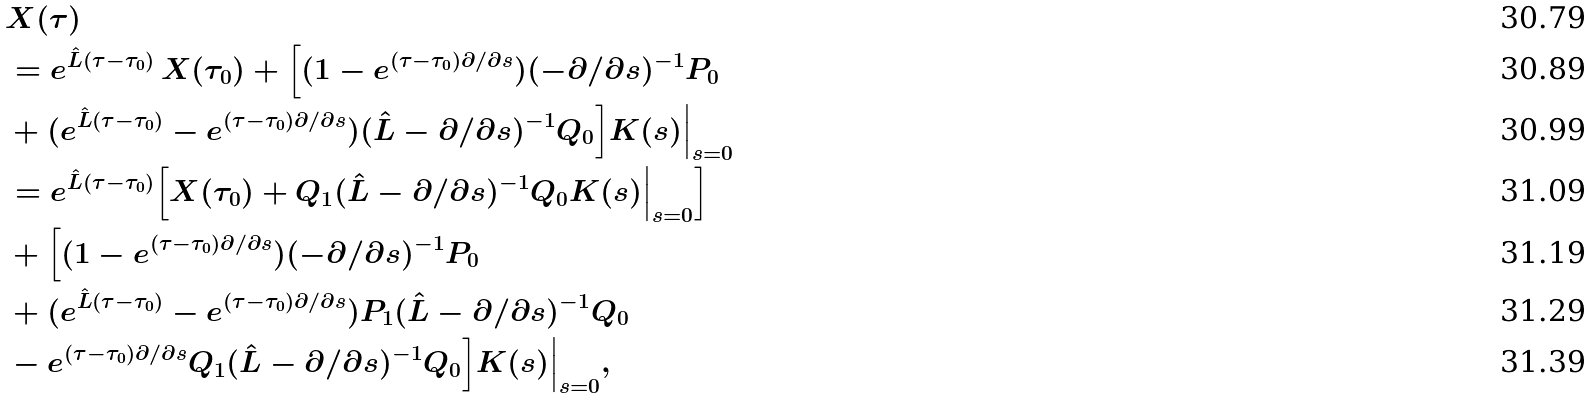<formula> <loc_0><loc_0><loc_500><loc_500>& X ( \tau ) \\ & = e ^ { \hat { L } ( \tau - \tau _ { 0 } ) } \, X ( \tau _ { 0 } ) + \Big [ ( 1 - e ^ { ( \tau - \tau _ { 0 } ) \partial / \partial s } ) ( - \partial / \partial s ) ^ { - 1 } P _ { 0 } \\ & + ( e ^ { \hat { L } ( \tau - \tau _ { 0 } ) } - e ^ { ( \tau - \tau _ { 0 } ) \partial / \partial s } ) ( \hat { L } - \partial / \partial s ) ^ { - 1 } Q _ { 0 } \Big ] K ( s ) \Big | _ { s = 0 } \\ & = e ^ { \hat { L } ( \tau - \tau _ { 0 } ) } \Big [ X ( \tau _ { 0 } ) + Q _ { 1 } ( \hat { L } - \partial / \partial s ) ^ { - 1 } Q _ { 0 } K ( s ) \Big | _ { s = 0 } \Big ] \\ & + \Big [ ( 1 - e ^ { ( \tau - \tau _ { 0 } ) \partial / \partial s } ) ( - \partial / \partial s ) ^ { - 1 } P _ { 0 } \\ & + ( e ^ { \hat { L } ( \tau - \tau _ { 0 } ) } - e ^ { ( \tau - \tau _ { 0 } ) \partial / \partial s } ) P _ { 1 } ( \hat { L } - \partial / \partial s ) ^ { - 1 } Q _ { 0 } \\ & - e ^ { ( \tau - \tau _ { 0 } ) \partial / \partial s } Q _ { 1 } ( \hat { L } - \partial / \partial s ) ^ { - 1 } Q _ { 0 } \Big ] K ( s ) \Big | _ { s = 0 } ,</formula> 